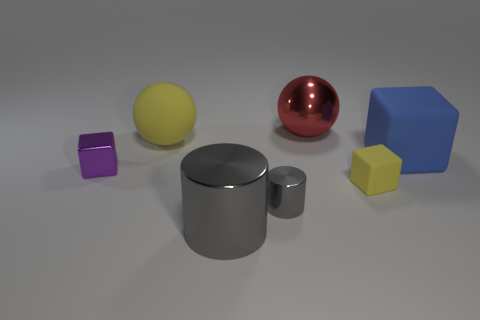Add 2 large purple rubber blocks. How many objects exist? 9 Subtract all cylinders. How many objects are left? 5 Add 7 yellow matte spheres. How many yellow matte spheres are left? 8 Add 3 tiny red rubber things. How many tiny red rubber things exist? 3 Subtract 0 cyan cylinders. How many objects are left? 7 Subtract all yellow rubber things. Subtract all red shiny things. How many objects are left? 4 